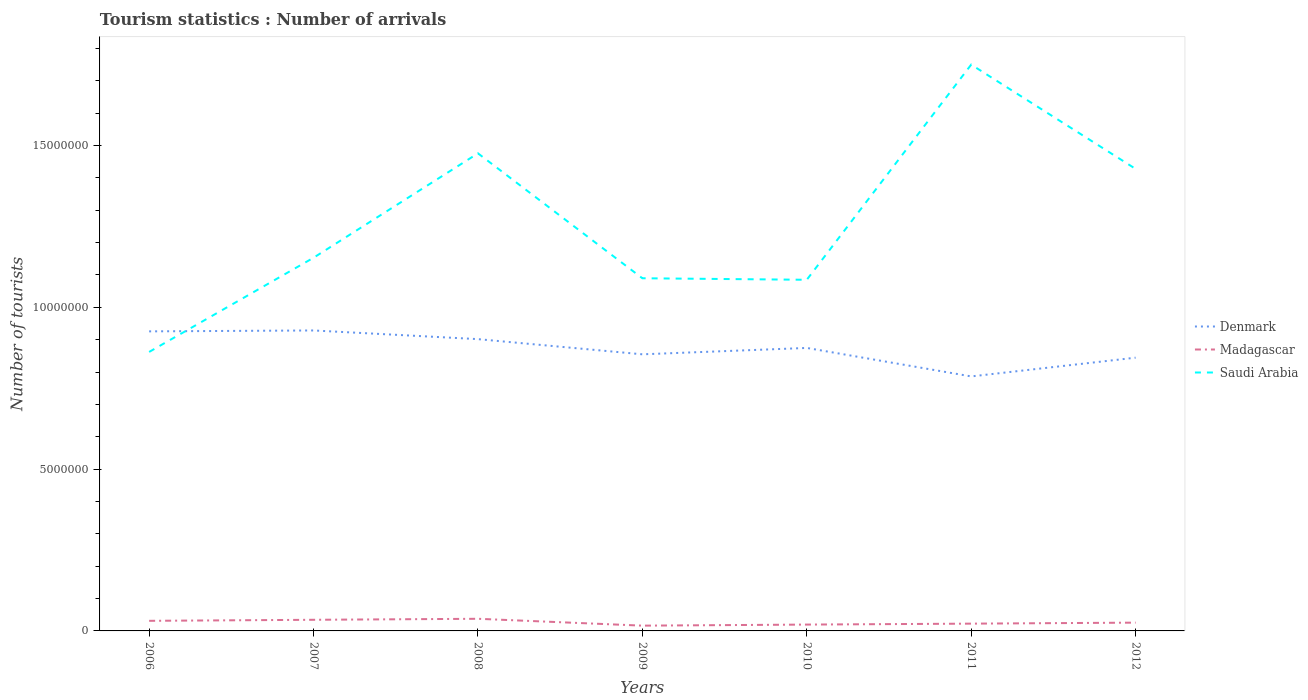Does the line corresponding to Madagascar intersect with the line corresponding to Saudi Arabia?
Your answer should be compact. No. Across all years, what is the maximum number of tourist arrivals in Madagascar?
Provide a succinct answer. 1.63e+05. In which year was the number of tourist arrivals in Denmark maximum?
Your answer should be compact. 2011. What is the total number of tourist arrivals in Saudi Arabia in the graph?
Your response must be concise. -6.14e+06. What is the difference between the highest and the second highest number of tourist arrivals in Madagascar?
Give a very brief answer. 2.12e+05. What is the difference between the highest and the lowest number of tourist arrivals in Saudi Arabia?
Provide a short and direct response. 3. How many lines are there?
Keep it short and to the point. 3. How many years are there in the graph?
Make the answer very short. 7. Does the graph contain grids?
Keep it short and to the point. No. How many legend labels are there?
Your answer should be compact. 3. How are the legend labels stacked?
Make the answer very short. Vertical. What is the title of the graph?
Make the answer very short. Tourism statistics : Number of arrivals. Does "Kenya" appear as one of the legend labels in the graph?
Ensure brevity in your answer.  No. What is the label or title of the X-axis?
Offer a terse response. Years. What is the label or title of the Y-axis?
Offer a terse response. Number of tourists. What is the Number of tourists of Denmark in 2006?
Your answer should be compact. 9.26e+06. What is the Number of tourists of Madagascar in 2006?
Provide a short and direct response. 3.12e+05. What is the Number of tourists in Saudi Arabia in 2006?
Ensure brevity in your answer.  8.62e+06. What is the Number of tourists of Denmark in 2007?
Your response must be concise. 9.28e+06. What is the Number of tourists in Madagascar in 2007?
Give a very brief answer. 3.44e+05. What is the Number of tourists of Saudi Arabia in 2007?
Your response must be concise. 1.15e+07. What is the Number of tourists of Denmark in 2008?
Make the answer very short. 9.02e+06. What is the Number of tourists of Madagascar in 2008?
Provide a succinct answer. 3.75e+05. What is the Number of tourists of Saudi Arabia in 2008?
Provide a short and direct response. 1.48e+07. What is the Number of tourists of Denmark in 2009?
Give a very brief answer. 8.55e+06. What is the Number of tourists of Madagascar in 2009?
Provide a short and direct response. 1.63e+05. What is the Number of tourists in Saudi Arabia in 2009?
Make the answer very short. 1.09e+07. What is the Number of tourists of Denmark in 2010?
Keep it short and to the point. 8.74e+06. What is the Number of tourists of Madagascar in 2010?
Make the answer very short. 1.96e+05. What is the Number of tourists in Saudi Arabia in 2010?
Keep it short and to the point. 1.08e+07. What is the Number of tourists of Denmark in 2011?
Keep it short and to the point. 7.86e+06. What is the Number of tourists in Madagascar in 2011?
Your answer should be very brief. 2.25e+05. What is the Number of tourists in Saudi Arabia in 2011?
Your answer should be very brief. 1.75e+07. What is the Number of tourists in Denmark in 2012?
Offer a very short reply. 8.44e+06. What is the Number of tourists of Madagascar in 2012?
Offer a very short reply. 2.56e+05. What is the Number of tourists of Saudi Arabia in 2012?
Offer a very short reply. 1.43e+07. Across all years, what is the maximum Number of tourists in Denmark?
Your answer should be very brief. 9.28e+06. Across all years, what is the maximum Number of tourists in Madagascar?
Your answer should be compact. 3.75e+05. Across all years, what is the maximum Number of tourists in Saudi Arabia?
Offer a terse response. 1.75e+07. Across all years, what is the minimum Number of tourists of Denmark?
Make the answer very short. 7.86e+06. Across all years, what is the minimum Number of tourists of Madagascar?
Keep it short and to the point. 1.63e+05. Across all years, what is the minimum Number of tourists of Saudi Arabia?
Your response must be concise. 8.62e+06. What is the total Number of tourists of Denmark in the graph?
Your response must be concise. 6.12e+07. What is the total Number of tourists of Madagascar in the graph?
Keep it short and to the point. 1.87e+06. What is the total Number of tourists of Saudi Arabia in the graph?
Your answer should be compact. 8.84e+07. What is the difference between the Number of tourists of Denmark in 2006 and that in 2007?
Give a very brief answer. -2.80e+04. What is the difference between the Number of tourists in Madagascar in 2006 and that in 2007?
Your response must be concise. -3.20e+04. What is the difference between the Number of tourists in Saudi Arabia in 2006 and that in 2007?
Provide a succinct answer. -2.91e+06. What is the difference between the Number of tourists of Denmark in 2006 and that in 2008?
Keep it short and to the point. 2.40e+05. What is the difference between the Number of tourists in Madagascar in 2006 and that in 2008?
Offer a terse response. -6.30e+04. What is the difference between the Number of tourists of Saudi Arabia in 2006 and that in 2008?
Your response must be concise. -6.14e+06. What is the difference between the Number of tourists of Denmark in 2006 and that in 2009?
Offer a terse response. 7.09e+05. What is the difference between the Number of tourists of Madagascar in 2006 and that in 2009?
Offer a very short reply. 1.49e+05. What is the difference between the Number of tourists of Saudi Arabia in 2006 and that in 2009?
Keep it short and to the point. -2.28e+06. What is the difference between the Number of tourists of Denmark in 2006 and that in 2010?
Provide a succinct answer. 5.12e+05. What is the difference between the Number of tourists of Madagascar in 2006 and that in 2010?
Your response must be concise. 1.16e+05. What is the difference between the Number of tourists of Saudi Arabia in 2006 and that in 2010?
Ensure brevity in your answer.  -2.23e+06. What is the difference between the Number of tourists in Denmark in 2006 and that in 2011?
Provide a succinct answer. 1.39e+06. What is the difference between the Number of tourists of Madagascar in 2006 and that in 2011?
Give a very brief answer. 8.70e+04. What is the difference between the Number of tourists of Saudi Arabia in 2006 and that in 2011?
Provide a succinct answer. -8.88e+06. What is the difference between the Number of tourists in Denmark in 2006 and that in 2012?
Your response must be concise. 8.13e+05. What is the difference between the Number of tourists of Madagascar in 2006 and that in 2012?
Offer a very short reply. 5.60e+04. What is the difference between the Number of tourists of Saudi Arabia in 2006 and that in 2012?
Make the answer very short. -5.66e+06. What is the difference between the Number of tourists of Denmark in 2007 and that in 2008?
Give a very brief answer. 2.68e+05. What is the difference between the Number of tourists of Madagascar in 2007 and that in 2008?
Your answer should be compact. -3.10e+04. What is the difference between the Number of tourists in Saudi Arabia in 2007 and that in 2008?
Your answer should be compact. -3.23e+06. What is the difference between the Number of tourists in Denmark in 2007 and that in 2009?
Offer a very short reply. 7.37e+05. What is the difference between the Number of tourists of Madagascar in 2007 and that in 2009?
Ensure brevity in your answer.  1.81e+05. What is the difference between the Number of tourists in Saudi Arabia in 2007 and that in 2009?
Give a very brief answer. 6.34e+05. What is the difference between the Number of tourists of Denmark in 2007 and that in 2010?
Your answer should be compact. 5.40e+05. What is the difference between the Number of tourists of Madagascar in 2007 and that in 2010?
Provide a short and direct response. 1.48e+05. What is the difference between the Number of tourists of Saudi Arabia in 2007 and that in 2010?
Give a very brief answer. 6.81e+05. What is the difference between the Number of tourists in Denmark in 2007 and that in 2011?
Provide a short and direct response. 1.42e+06. What is the difference between the Number of tourists of Madagascar in 2007 and that in 2011?
Keep it short and to the point. 1.19e+05. What is the difference between the Number of tourists in Saudi Arabia in 2007 and that in 2011?
Provide a succinct answer. -5.97e+06. What is the difference between the Number of tourists of Denmark in 2007 and that in 2012?
Your response must be concise. 8.41e+05. What is the difference between the Number of tourists of Madagascar in 2007 and that in 2012?
Provide a short and direct response. 8.80e+04. What is the difference between the Number of tourists of Saudi Arabia in 2007 and that in 2012?
Offer a terse response. -2.74e+06. What is the difference between the Number of tourists of Denmark in 2008 and that in 2009?
Offer a terse response. 4.69e+05. What is the difference between the Number of tourists of Madagascar in 2008 and that in 2009?
Provide a short and direct response. 2.12e+05. What is the difference between the Number of tourists of Saudi Arabia in 2008 and that in 2009?
Provide a short and direct response. 3.86e+06. What is the difference between the Number of tourists of Denmark in 2008 and that in 2010?
Your response must be concise. 2.72e+05. What is the difference between the Number of tourists in Madagascar in 2008 and that in 2010?
Give a very brief answer. 1.79e+05. What is the difference between the Number of tourists in Saudi Arabia in 2008 and that in 2010?
Provide a succinct answer. 3.91e+06. What is the difference between the Number of tourists in Denmark in 2008 and that in 2011?
Provide a short and direct response. 1.15e+06. What is the difference between the Number of tourists in Saudi Arabia in 2008 and that in 2011?
Provide a short and direct response. -2.74e+06. What is the difference between the Number of tourists of Denmark in 2008 and that in 2012?
Offer a terse response. 5.73e+05. What is the difference between the Number of tourists of Madagascar in 2008 and that in 2012?
Provide a succinct answer. 1.19e+05. What is the difference between the Number of tourists of Saudi Arabia in 2008 and that in 2012?
Your response must be concise. 4.81e+05. What is the difference between the Number of tourists in Denmark in 2009 and that in 2010?
Your answer should be very brief. -1.97e+05. What is the difference between the Number of tourists in Madagascar in 2009 and that in 2010?
Offer a terse response. -3.30e+04. What is the difference between the Number of tourists in Saudi Arabia in 2009 and that in 2010?
Your answer should be very brief. 4.70e+04. What is the difference between the Number of tourists of Denmark in 2009 and that in 2011?
Ensure brevity in your answer.  6.83e+05. What is the difference between the Number of tourists in Madagascar in 2009 and that in 2011?
Ensure brevity in your answer.  -6.20e+04. What is the difference between the Number of tourists in Saudi Arabia in 2009 and that in 2011?
Offer a very short reply. -6.60e+06. What is the difference between the Number of tourists in Denmark in 2009 and that in 2012?
Make the answer very short. 1.04e+05. What is the difference between the Number of tourists in Madagascar in 2009 and that in 2012?
Provide a succinct answer. -9.30e+04. What is the difference between the Number of tourists of Saudi Arabia in 2009 and that in 2012?
Your answer should be compact. -3.38e+06. What is the difference between the Number of tourists of Denmark in 2010 and that in 2011?
Offer a very short reply. 8.80e+05. What is the difference between the Number of tourists of Madagascar in 2010 and that in 2011?
Your answer should be very brief. -2.90e+04. What is the difference between the Number of tourists in Saudi Arabia in 2010 and that in 2011?
Provide a short and direct response. -6.65e+06. What is the difference between the Number of tourists of Denmark in 2010 and that in 2012?
Your answer should be very brief. 3.01e+05. What is the difference between the Number of tourists of Madagascar in 2010 and that in 2012?
Make the answer very short. -6.00e+04. What is the difference between the Number of tourists of Saudi Arabia in 2010 and that in 2012?
Provide a succinct answer. -3.43e+06. What is the difference between the Number of tourists in Denmark in 2011 and that in 2012?
Give a very brief answer. -5.79e+05. What is the difference between the Number of tourists of Madagascar in 2011 and that in 2012?
Make the answer very short. -3.10e+04. What is the difference between the Number of tourists in Saudi Arabia in 2011 and that in 2012?
Keep it short and to the point. 3.22e+06. What is the difference between the Number of tourists of Denmark in 2006 and the Number of tourists of Madagascar in 2007?
Make the answer very short. 8.91e+06. What is the difference between the Number of tourists in Denmark in 2006 and the Number of tourists in Saudi Arabia in 2007?
Offer a very short reply. -2.28e+06. What is the difference between the Number of tourists in Madagascar in 2006 and the Number of tourists in Saudi Arabia in 2007?
Keep it short and to the point. -1.12e+07. What is the difference between the Number of tourists in Denmark in 2006 and the Number of tourists in Madagascar in 2008?
Make the answer very short. 8.88e+06. What is the difference between the Number of tourists of Denmark in 2006 and the Number of tourists of Saudi Arabia in 2008?
Keep it short and to the point. -5.50e+06. What is the difference between the Number of tourists in Madagascar in 2006 and the Number of tourists in Saudi Arabia in 2008?
Make the answer very short. -1.44e+07. What is the difference between the Number of tourists of Denmark in 2006 and the Number of tourists of Madagascar in 2009?
Make the answer very short. 9.09e+06. What is the difference between the Number of tourists in Denmark in 2006 and the Number of tourists in Saudi Arabia in 2009?
Provide a short and direct response. -1.64e+06. What is the difference between the Number of tourists of Madagascar in 2006 and the Number of tourists of Saudi Arabia in 2009?
Your answer should be compact. -1.06e+07. What is the difference between the Number of tourists in Denmark in 2006 and the Number of tourists in Madagascar in 2010?
Provide a short and direct response. 9.06e+06. What is the difference between the Number of tourists in Denmark in 2006 and the Number of tourists in Saudi Arabia in 2010?
Ensure brevity in your answer.  -1.59e+06. What is the difference between the Number of tourists in Madagascar in 2006 and the Number of tourists in Saudi Arabia in 2010?
Ensure brevity in your answer.  -1.05e+07. What is the difference between the Number of tourists of Denmark in 2006 and the Number of tourists of Madagascar in 2011?
Keep it short and to the point. 9.03e+06. What is the difference between the Number of tourists in Denmark in 2006 and the Number of tourists in Saudi Arabia in 2011?
Provide a succinct answer. -8.24e+06. What is the difference between the Number of tourists of Madagascar in 2006 and the Number of tourists of Saudi Arabia in 2011?
Offer a terse response. -1.72e+07. What is the difference between the Number of tourists in Denmark in 2006 and the Number of tourists in Madagascar in 2012?
Ensure brevity in your answer.  9.00e+06. What is the difference between the Number of tourists in Denmark in 2006 and the Number of tourists in Saudi Arabia in 2012?
Give a very brief answer. -5.02e+06. What is the difference between the Number of tourists of Madagascar in 2006 and the Number of tourists of Saudi Arabia in 2012?
Provide a succinct answer. -1.40e+07. What is the difference between the Number of tourists of Denmark in 2007 and the Number of tourists of Madagascar in 2008?
Give a very brief answer. 8.91e+06. What is the difference between the Number of tourists of Denmark in 2007 and the Number of tourists of Saudi Arabia in 2008?
Your answer should be very brief. -5.47e+06. What is the difference between the Number of tourists in Madagascar in 2007 and the Number of tourists in Saudi Arabia in 2008?
Keep it short and to the point. -1.44e+07. What is the difference between the Number of tourists in Denmark in 2007 and the Number of tourists in Madagascar in 2009?
Your response must be concise. 9.12e+06. What is the difference between the Number of tourists of Denmark in 2007 and the Number of tourists of Saudi Arabia in 2009?
Provide a short and direct response. -1.61e+06. What is the difference between the Number of tourists of Madagascar in 2007 and the Number of tourists of Saudi Arabia in 2009?
Give a very brief answer. -1.06e+07. What is the difference between the Number of tourists in Denmark in 2007 and the Number of tourists in Madagascar in 2010?
Give a very brief answer. 9.09e+06. What is the difference between the Number of tourists of Denmark in 2007 and the Number of tourists of Saudi Arabia in 2010?
Keep it short and to the point. -1.57e+06. What is the difference between the Number of tourists in Madagascar in 2007 and the Number of tourists in Saudi Arabia in 2010?
Your response must be concise. -1.05e+07. What is the difference between the Number of tourists in Denmark in 2007 and the Number of tourists in Madagascar in 2011?
Provide a short and direct response. 9.06e+06. What is the difference between the Number of tourists of Denmark in 2007 and the Number of tourists of Saudi Arabia in 2011?
Ensure brevity in your answer.  -8.21e+06. What is the difference between the Number of tourists of Madagascar in 2007 and the Number of tourists of Saudi Arabia in 2011?
Your answer should be very brief. -1.72e+07. What is the difference between the Number of tourists of Denmark in 2007 and the Number of tourists of Madagascar in 2012?
Provide a succinct answer. 9.03e+06. What is the difference between the Number of tourists in Denmark in 2007 and the Number of tourists in Saudi Arabia in 2012?
Make the answer very short. -4.99e+06. What is the difference between the Number of tourists in Madagascar in 2007 and the Number of tourists in Saudi Arabia in 2012?
Provide a short and direct response. -1.39e+07. What is the difference between the Number of tourists of Denmark in 2008 and the Number of tourists of Madagascar in 2009?
Offer a very short reply. 8.85e+06. What is the difference between the Number of tourists of Denmark in 2008 and the Number of tourists of Saudi Arabia in 2009?
Offer a very short reply. -1.88e+06. What is the difference between the Number of tourists of Madagascar in 2008 and the Number of tourists of Saudi Arabia in 2009?
Keep it short and to the point. -1.05e+07. What is the difference between the Number of tourists in Denmark in 2008 and the Number of tourists in Madagascar in 2010?
Provide a short and direct response. 8.82e+06. What is the difference between the Number of tourists in Denmark in 2008 and the Number of tourists in Saudi Arabia in 2010?
Provide a succinct answer. -1.83e+06. What is the difference between the Number of tourists in Madagascar in 2008 and the Number of tourists in Saudi Arabia in 2010?
Your answer should be very brief. -1.05e+07. What is the difference between the Number of tourists in Denmark in 2008 and the Number of tourists in Madagascar in 2011?
Keep it short and to the point. 8.79e+06. What is the difference between the Number of tourists in Denmark in 2008 and the Number of tourists in Saudi Arabia in 2011?
Provide a succinct answer. -8.48e+06. What is the difference between the Number of tourists of Madagascar in 2008 and the Number of tourists of Saudi Arabia in 2011?
Your response must be concise. -1.71e+07. What is the difference between the Number of tourists in Denmark in 2008 and the Number of tourists in Madagascar in 2012?
Keep it short and to the point. 8.76e+06. What is the difference between the Number of tourists of Denmark in 2008 and the Number of tourists of Saudi Arabia in 2012?
Provide a short and direct response. -5.26e+06. What is the difference between the Number of tourists of Madagascar in 2008 and the Number of tourists of Saudi Arabia in 2012?
Your response must be concise. -1.39e+07. What is the difference between the Number of tourists in Denmark in 2009 and the Number of tourists in Madagascar in 2010?
Your answer should be compact. 8.35e+06. What is the difference between the Number of tourists of Denmark in 2009 and the Number of tourists of Saudi Arabia in 2010?
Provide a short and direct response. -2.30e+06. What is the difference between the Number of tourists in Madagascar in 2009 and the Number of tourists in Saudi Arabia in 2010?
Make the answer very short. -1.07e+07. What is the difference between the Number of tourists of Denmark in 2009 and the Number of tourists of Madagascar in 2011?
Give a very brief answer. 8.32e+06. What is the difference between the Number of tourists in Denmark in 2009 and the Number of tourists in Saudi Arabia in 2011?
Provide a succinct answer. -8.95e+06. What is the difference between the Number of tourists of Madagascar in 2009 and the Number of tourists of Saudi Arabia in 2011?
Ensure brevity in your answer.  -1.73e+07. What is the difference between the Number of tourists of Denmark in 2009 and the Number of tourists of Madagascar in 2012?
Offer a terse response. 8.29e+06. What is the difference between the Number of tourists of Denmark in 2009 and the Number of tourists of Saudi Arabia in 2012?
Make the answer very short. -5.73e+06. What is the difference between the Number of tourists in Madagascar in 2009 and the Number of tourists in Saudi Arabia in 2012?
Make the answer very short. -1.41e+07. What is the difference between the Number of tourists in Denmark in 2010 and the Number of tourists in Madagascar in 2011?
Your response must be concise. 8.52e+06. What is the difference between the Number of tourists in Denmark in 2010 and the Number of tourists in Saudi Arabia in 2011?
Give a very brief answer. -8.75e+06. What is the difference between the Number of tourists in Madagascar in 2010 and the Number of tourists in Saudi Arabia in 2011?
Provide a short and direct response. -1.73e+07. What is the difference between the Number of tourists of Denmark in 2010 and the Number of tourists of Madagascar in 2012?
Your response must be concise. 8.49e+06. What is the difference between the Number of tourists of Denmark in 2010 and the Number of tourists of Saudi Arabia in 2012?
Keep it short and to the point. -5.53e+06. What is the difference between the Number of tourists in Madagascar in 2010 and the Number of tourists in Saudi Arabia in 2012?
Ensure brevity in your answer.  -1.41e+07. What is the difference between the Number of tourists in Denmark in 2011 and the Number of tourists in Madagascar in 2012?
Your answer should be compact. 7.61e+06. What is the difference between the Number of tourists in Denmark in 2011 and the Number of tourists in Saudi Arabia in 2012?
Offer a very short reply. -6.41e+06. What is the difference between the Number of tourists of Madagascar in 2011 and the Number of tourists of Saudi Arabia in 2012?
Ensure brevity in your answer.  -1.41e+07. What is the average Number of tourists of Denmark per year?
Provide a succinct answer. 8.74e+06. What is the average Number of tourists in Madagascar per year?
Give a very brief answer. 2.67e+05. What is the average Number of tourists of Saudi Arabia per year?
Your answer should be very brief. 1.26e+07. In the year 2006, what is the difference between the Number of tourists in Denmark and Number of tourists in Madagascar?
Make the answer very short. 8.94e+06. In the year 2006, what is the difference between the Number of tourists in Denmark and Number of tourists in Saudi Arabia?
Provide a succinct answer. 6.36e+05. In the year 2006, what is the difference between the Number of tourists of Madagascar and Number of tourists of Saudi Arabia?
Your answer should be very brief. -8.31e+06. In the year 2007, what is the difference between the Number of tourists in Denmark and Number of tourists in Madagascar?
Ensure brevity in your answer.  8.94e+06. In the year 2007, what is the difference between the Number of tourists in Denmark and Number of tourists in Saudi Arabia?
Your answer should be very brief. -2.25e+06. In the year 2007, what is the difference between the Number of tourists of Madagascar and Number of tourists of Saudi Arabia?
Your answer should be compact. -1.12e+07. In the year 2008, what is the difference between the Number of tourists of Denmark and Number of tourists of Madagascar?
Give a very brief answer. 8.64e+06. In the year 2008, what is the difference between the Number of tourists in Denmark and Number of tourists in Saudi Arabia?
Your response must be concise. -5.74e+06. In the year 2008, what is the difference between the Number of tourists of Madagascar and Number of tourists of Saudi Arabia?
Your answer should be very brief. -1.44e+07. In the year 2009, what is the difference between the Number of tourists in Denmark and Number of tourists in Madagascar?
Offer a very short reply. 8.38e+06. In the year 2009, what is the difference between the Number of tourists in Denmark and Number of tourists in Saudi Arabia?
Offer a very short reply. -2.35e+06. In the year 2009, what is the difference between the Number of tourists of Madagascar and Number of tourists of Saudi Arabia?
Ensure brevity in your answer.  -1.07e+07. In the year 2010, what is the difference between the Number of tourists in Denmark and Number of tourists in Madagascar?
Give a very brief answer. 8.55e+06. In the year 2010, what is the difference between the Number of tourists of Denmark and Number of tourists of Saudi Arabia?
Your answer should be compact. -2.11e+06. In the year 2010, what is the difference between the Number of tourists in Madagascar and Number of tourists in Saudi Arabia?
Provide a succinct answer. -1.07e+07. In the year 2011, what is the difference between the Number of tourists of Denmark and Number of tourists of Madagascar?
Give a very brief answer. 7.64e+06. In the year 2011, what is the difference between the Number of tourists of Denmark and Number of tourists of Saudi Arabia?
Your answer should be compact. -9.63e+06. In the year 2011, what is the difference between the Number of tourists in Madagascar and Number of tourists in Saudi Arabia?
Provide a short and direct response. -1.73e+07. In the year 2012, what is the difference between the Number of tourists of Denmark and Number of tourists of Madagascar?
Your response must be concise. 8.19e+06. In the year 2012, what is the difference between the Number of tourists in Denmark and Number of tourists in Saudi Arabia?
Give a very brief answer. -5.83e+06. In the year 2012, what is the difference between the Number of tourists of Madagascar and Number of tourists of Saudi Arabia?
Your answer should be compact. -1.40e+07. What is the ratio of the Number of tourists in Madagascar in 2006 to that in 2007?
Your answer should be compact. 0.91. What is the ratio of the Number of tourists of Saudi Arabia in 2006 to that in 2007?
Give a very brief answer. 0.75. What is the ratio of the Number of tourists of Denmark in 2006 to that in 2008?
Ensure brevity in your answer.  1.03. What is the ratio of the Number of tourists of Madagascar in 2006 to that in 2008?
Ensure brevity in your answer.  0.83. What is the ratio of the Number of tourists of Saudi Arabia in 2006 to that in 2008?
Ensure brevity in your answer.  0.58. What is the ratio of the Number of tourists in Denmark in 2006 to that in 2009?
Ensure brevity in your answer.  1.08. What is the ratio of the Number of tourists in Madagascar in 2006 to that in 2009?
Provide a short and direct response. 1.91. What is the ratio of the Number of tourists of Saudi Arabia in 2006 to that in 2009?
Keep it short and to the point. 0.79. What is the ratio of the Number of tourists of Denmark in 2006 to that in 2010?
Your answer should be very brief. 1.06. What is the ratio of the Number of tourists of Madagascar in 2006 to that in 2010?
Provide a succinct answer. 1.59. What is the ratio of the Number of tourists in Saudi Arabia in 2006 to that in 2010?
Provide a succinct answer. 0.79. What is the ratio of the Number of tourists of Denmark in 2006 to that in 2011?
Ensure brevity in your answer.  1.18. What is the ratio of the Number of tourists of Madagascar in 2006 to that in 2011?
Your answer should be very brief. 1.39. What is the ratio of the Number of tourists in Saudi Arabia in 2006 to that in 2011?
Provide a succinct answer. 0.49. What is the ratio of the Number of tourists of Denmark in 2006 to that in 2012?
Offer a very short reply. 1.1. What is the ratio of the Number of tourists of Madagascar in 2006 to that in 2012?
Provide a succinct answer. 1.22. What is the ratio of the Number of tourists in Saudi Arabia in 2006 to that in 2012?
Make the answer very short. 0.6. What is the ratio of the Number of tourists of Denmark in 2007 to that in 2008?
Keep it short and to the point. 1.03. What is the ratio of the Number of tourists of Madagascar in 2007 to that in 2008?
Provide a succinct answer. 0.92. What is the ratio of the Number of tourists of Saudi Arabia in 2007 to that in 2008?
Offer a terse response. 0.78. What is the ratio of the Number of tourists of Denmark in 2007 to that in 2009?
Offer a very short reply. 1.09. What is the ratio of the Number of tourists of Madagascar in 2007 to that in 2009?
Ensure brevity in your answer.  2.11. What is the ratio of the Number of tourists in Saudi Arabia in 2007 to that in 2009?
Keep it short and to the point. 1.06. What is the ratio of the Number of tourists of Denmark in 2007 to that in 2010?
Your answer should be very brief. 1.06. What is the ratio of the Number of tourists of Madagascar in 2007 to that in 2010?
Make the answer very short. 1.76. What is the ratio of the Number of tourists of Saudi Arabia in 2007 to that in 2010?
Your answer should be compact. 1.06. What is the ratio of the Number of tourists of Denmark in 2007 to that in 2011?
Ensure brevity in your answer.  1.18. What is the ratio of the Number of tourists of Madagascar in 2007 to that in 2011?
Your answer should be very brief. 1.53. What is the ratio of the Number of tourists of Saudi Arabia in 2007 to that in 2011?
Give a very brief answer. 0.66. What is the ratio of the Number of tourists in Denmark in 2007 to that in 2012?
Give a very brief answer. 1.1. What is the ratio of the Number of tourists of Madagascar in 2007 to that in 2012?
Your answer should be very brief. 1.34. What is the ratio of the Number of tourists of Saudi Arabia in 2007 to that in 2012?
Keep it short and to the point. 0.81. What is the ratio of the Number of tourists in Denmark in 2008 to that in 2009?
Give a very brief answer. 1.05. What is the ratio of the Number of tourists of Madagascar in 2008 to that in 2009?
Offer a terse response. 2.3. What is the ratio of the Number of tourists of Saudi Arabia in 2008 to that in 2009?
Your answer should be very brief. 1.35. What is the ratio of the Number of tourists of Denmark in 2008 to that in 2010?
Provide a short and direct response. 1.03. What is the ratio of the Number of tourists in Madagascar in 2008 to that in 2010?
Your answer should be very brief. 1.91. What is the ratio of the Number of tourists of Saudi Arabia in 2008 to that in 2010?
Keep it short and to the point. 1.36. What is the ratio of the Number of tourists of Denmark in 2008 to that in 2011?
Provide a short and direct response. 1.15. What is the ratio of the Number of tourists in Madagascar in 2008 to that in 2011?
Keep it short and to the point. 1.67. What is the ratio of the Number of tourists in Saudi Arabia in 2008 to that in 2011?
Provide a succinct answer. 0.84. What is the ratio of the Number of tourists of Denmark in 2008 to that in 2012?
Offer a very short reply. 1.07. What is the ratio of the Number of tourists of Madagascar in 2008 to that in 2012?
Offer a terse response. 1.46. What is the ratio of the Number of tourists in Saudi Arabia in 2008 to that in 2012?
Give a very brief answer. 1.03. What is the ratio of the Number of tourists in Denmark in 2009 to that in 2010?
Give a very brief answer. 0.98. What is the ratio of the Number of tourists of Madagascar in 2009 to that in 2010?
Your response must be concise. 0.83. What is the ratio of the Number of tourists of Denmark in 2009 to that in 2011?
Provide a succinct answer. 1.09. What is the ratio of the Number of tourists in Madagascar in 2009 to that in 2011?
Provide a short and direct response. 0.72. What is the ratio of the Number of tourists of Saudi Arabia in 2009 to that in 2011?
Offer a terse response. 0.62. What is the ratio of the Number of tourists in Denmark in 2009 to that in 2012?
Offer a terse response. 1.01. What is the ratio of the Number of tourists in Madagascar in 2009 to that in 2012?
Ensure brevity in your answer.  0.64. What is the ratio of the Number of tourists of Saudi Arabia in 2009 to that in 2012?
Keep it short and to the point. 0.76. What is the ratio of the Number of tourists of Denmark in 2010 to that in 2011?
Your response must be concise. 1.11. What is the ratio of the Number of tourists of Madagascar in 2010 to that in 2011?
Provide a short and direct response. 0.87. What is the ratio of the Number of tourists in Saudi Arabia in 2010 to that in 2011?
Make the answer very short. 0.62. What is the ratio of the Number of tourists in Denmark in 2010 to that in 2012?
Offer a very short reply. 1.04. What is the ratio of the Number of tourists of Madagascar in 2010 to that in 2012?
Make the answer very short. 0.77. What is the ratio of the Number of tourists in Saudi Arabia in 2010 to that in 2012?
Your answer should be compact. 0.76. What is the ratio of the Number of tourists in Denmark in 2011 to that in 2012?
Make the answer very short. 0.93. What is the ratio of the Number of tourists of Madagascar in 2011 to that in 2012?
Give a very brief answer. 0.88. What is the ratio of the Number of tourists in Saudi Arabia in 2011 to that in 2012?
Make the answer very short. 1.23. What is the difference between the highest and the second highest Number of tourists in Denmark?
Provide a short and direct response. 2.80e+04. What is the difference between the highest and the second highest Number of tourists in Madagascar?
Offer a terse response. 3.10e+04. What is the difference between the highest and the second highest Number of tourists of Saudi Arabia?
Your answer should be very brief. 2.74e+06. What is the difference between the highest and the lowest Number of tourists of Denmark?
Give a very brief answer. 1.42e+06. What is the difference between the highest and the lowest Number of tourists in Madagascar?
Offer a terse response. 2.12e+05. What is the difference between the highest and the lowest Number of tourists in Saudi Arabia?
Ensure brevity in your answer.  8.88e+06. 